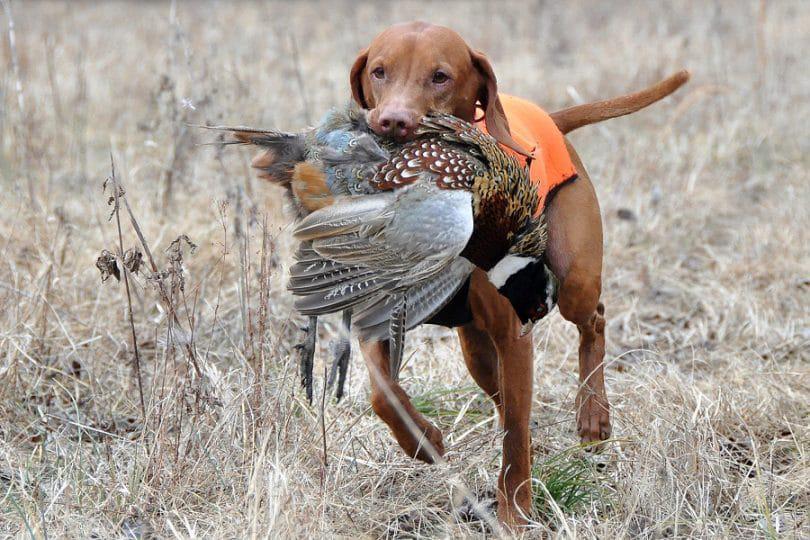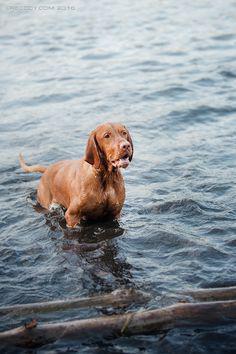The first image is the image on the left, the second image is the image on the right. Assess this claim about the two images: "The right image contains one dog that is partially submerged in water.". Correct or not? Answer yes or no. Yes. The first image is the image on the left, the second image is the image on the right. For the images shown, is this caption "The combined images include a dog in the water and a dog moving forward while carrying something in its mouth." true? Answer yes or no. Yes. 